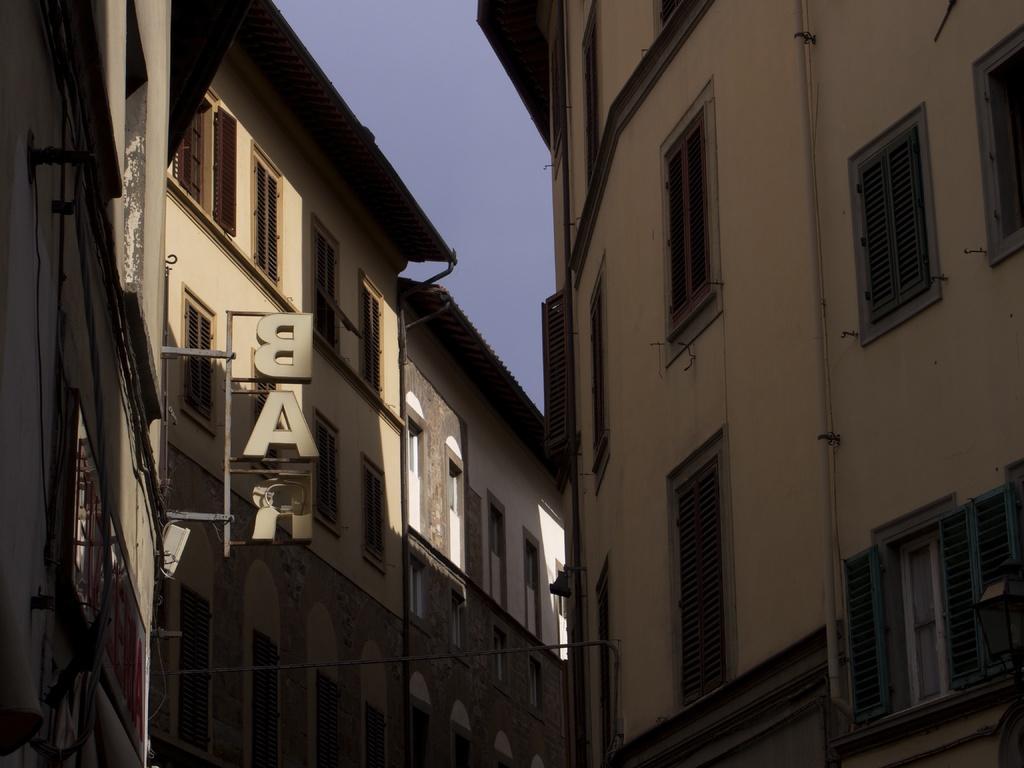Could you give a brief overview of what you see in this image? In the image I can see some buildings to which there are some windows and a stand to which there are some letters. 